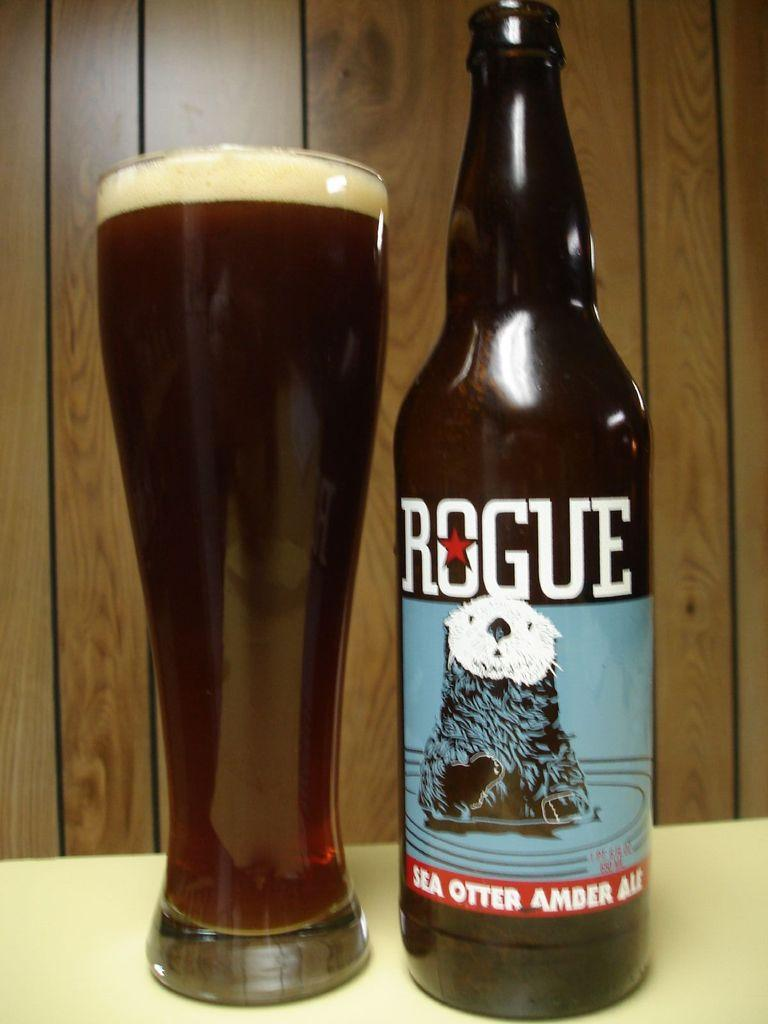Provide a one-sentence caption for the provided image. A rogue beer beverage poured in a glass with an otter as their logo. 